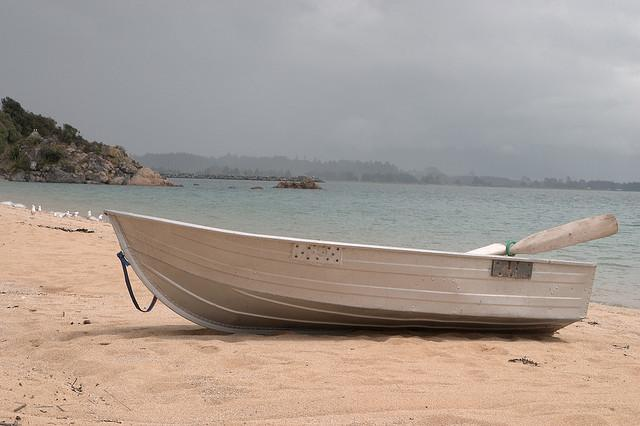What propels this boat?

Choices:
A) electricity
B) sail
C) oar
D) gas engine oar 